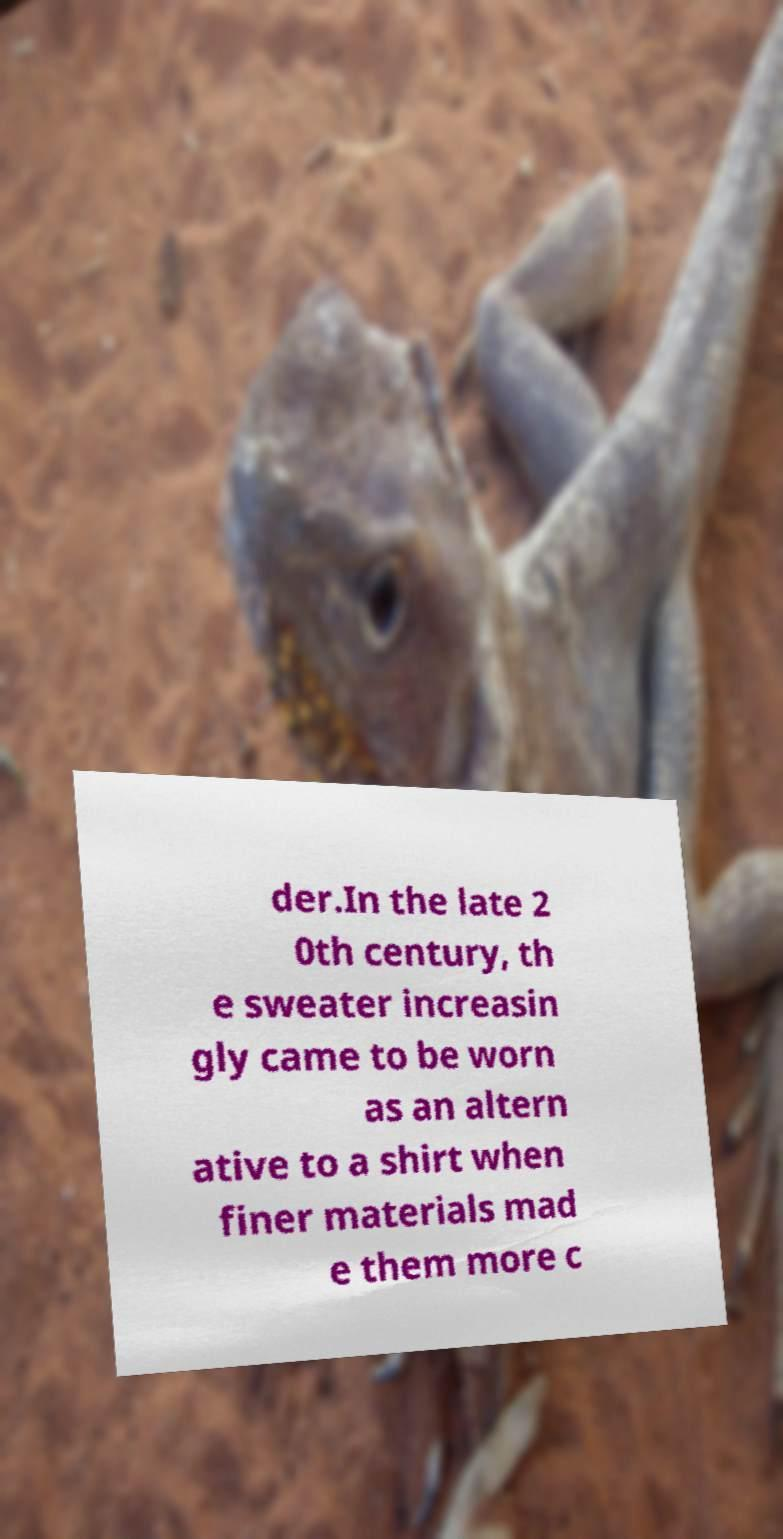For documentation purposes, I need the text within this image transcribed. Could you provide that? der.In the late 2 0th century, th e sweater increasin gly came to be worn as an altern ative to a shirt when finer materials mad e them more c 